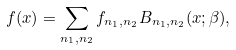Convert formula to latex. <formula><loc_0><loc_0><loc_500><loc_500>f ( x ) = \sum _ { n _ { 1 } , n _ { 2 } } f _ { n _ { 1 } , n _ { 2 } } B _ { n _ { 1 } , n _ { 2 } } ( x ; \beta ) ,</formula> 